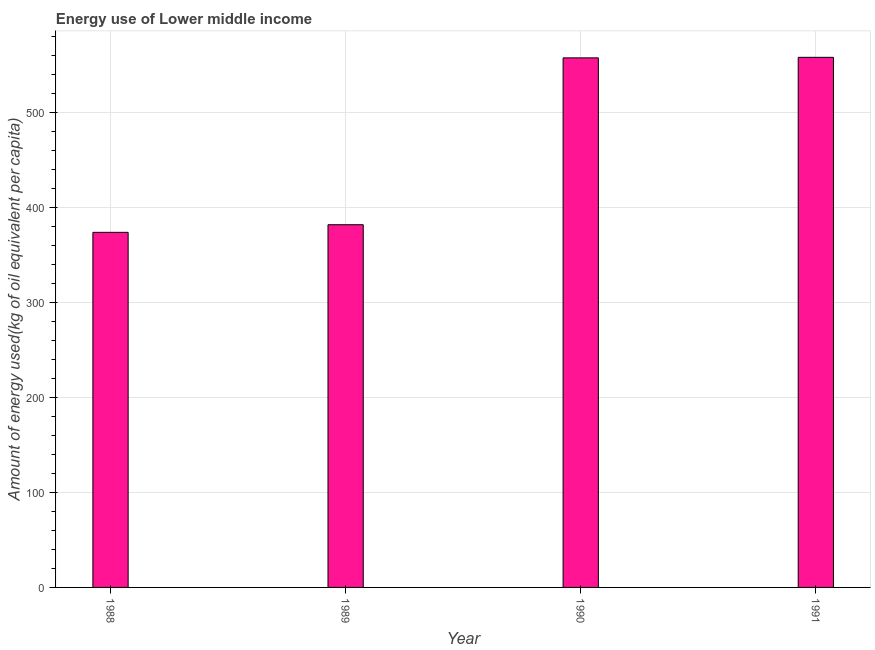Does the graph contain any zero values?
Make the answer very short. No. Does the graph contain grids?
Give a very brief answer. Yes. What is the title of the graph?
Give a very brief answer. Energy use of Lower middle income. What is the label or title of the Y-axis?
Give a very brief answer. Amount of energy used(kg of oil equivalent per capita). What is the amount of energy used in 1991?
Provide a short and direct response. 558.43. Across all years, what is the maximum amount of energy used?
Your answer should be compact. 558.43. Across all years, what is the minimum amount of energy used?
Offer a very short reply. 374.07. In which year was the amount of energy used maximum?
Give a very brief answer. 1991. What is the sum of the amount of energy used?
Your answer should be very brief. 1872.46. What is the difference between the amount of energy used in 1988 and 1991?
Your answer should be compact. -184.36. What is the average amount of energy used per year?
Provide a succinct answer. 468.12. What is the median amount of energy used?
Provide a short and direct response. 469.98. In how many years, is the amount of energy used greater than 320 kg?
Ensure brevity in your answer.  4. Do a majority of the years between 1991 and 1990 (inclusive) have amount of energy used greater than 340 kg?
Give a very brief answer. No. What is the ratio of the amount of energy used in 1989 to that in 1990?
Ensure brevity in your answer.  0.69. Is the amount of energy used in 1989 less than that in 1990?
Provide a succinct answer. Yes. What is the difference between the highest and the second highest amount of energy used?
Give a very brief answer. 0.57. What is the difference between the highest and the lowest amount of energy used?
Provide a short and direct response. 184.36. In how many years, is the amount of energy used greater than the average amount of energy used taken over all years?
Your response must be concise. 2. How many bars are there?
Your answer should be very brief. 4. Are all the bars in the graph horizontal?
Your response must be concise. No. What is the difference between two consecutive major ticks on the Y-axis?
Offer a terse response. 100. Are the values on the major ticks of Y-axis written in scientific E-notation?
Provide a short and direct response. No. What is the Amount of energy used(kg of oil equivalent per capita) in 1988?
Give a very brief answer. 374.07. What is the Amount of energy used(kg of oil equivalent per capita) of 1989?
Ensure brevity in your answer.  382.1. What is the Amount of energy used(kg of oil equivalent per capita) in 1990?
Provide a succinct answer. 557.86. What is the Amount of energy used(kg of oil equivalent per capita) in 1991?
Your answer should be very brief. 558.43. What is the difference between the Amount of energy used(kg of oil equivalent per capita) in 1988 and 1989?
Offer a very short reply. -8.02. What is the difference between the Amount of energy used(kg of oil equivalent per capita) in 1988 and 1990?
Offer a terse response. -183.79. What is the difference between the Amount of energy used(kg of oil equivalent per capita) in 1988 and 1991?
Provide a short and direct response. -184.36. What is the difference between the Amount of energy used(kg of oil equivalent per capita) in 1989 and 1990?
Your answer should be compact. -175.77. What is the difference between the Amount of energy used(kg of oil equivalent per capita) in 1989 and 1991?
Make the answer very short. -176.34. What is the difference between the Amount of energy used(kg of oil equivalent per capita) in 1990 and 1991?
Your response must be concise. -0.57. What is the ratio of the Amount of energy used(kg of oil equivalent per capita) in 1988 to that in 1990?
Offer a terse response. 0.67. What is the ratio of the Amount of energy used(kg of oil equivalent per capita) in 1988 to that in 1991?
Make the answer very short. 0.67. What is the ratio of the Amount of energy used(kg of oil equivalent per capita) in 1989 to that in 1990?
Ensure brevity in your answer.  0.69. What is the ratio of the Amount of energy used(kg of oil equivalent per capita) in 1989 to that in 1991?
Give a very brief answer. 0.68. 